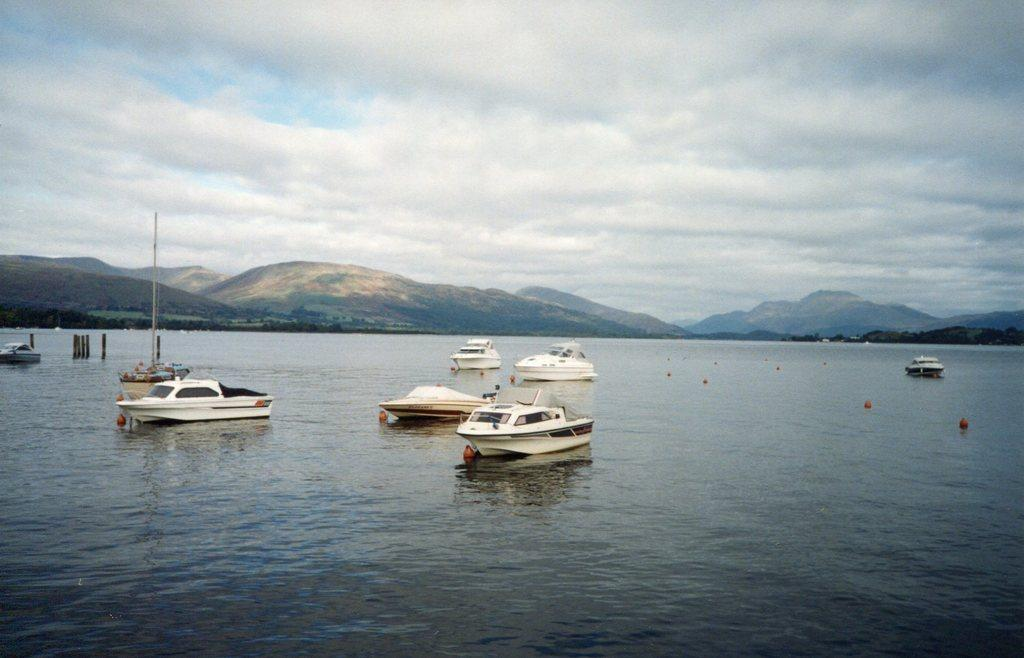What type of vehicles can be seen on the water in the image? There are ships on the water in the image. What safety feature is present in the image? Barrier poles are present in the image. What type of landscape can be seen in the image? There are hills visible in the image. What is visible in the sky in the image? The sky is visible in the image, and clouds are present. What historical event is depicted in the image? There is no historical event depicted in the image; it shows ships on the water, barrier poles, hills, and the sky with clouds. Can you tell me how fast the ships are running in the image? Ships do not run; they move through the water using engines or sails. In the image, the speed of the ships cannot be determined. 